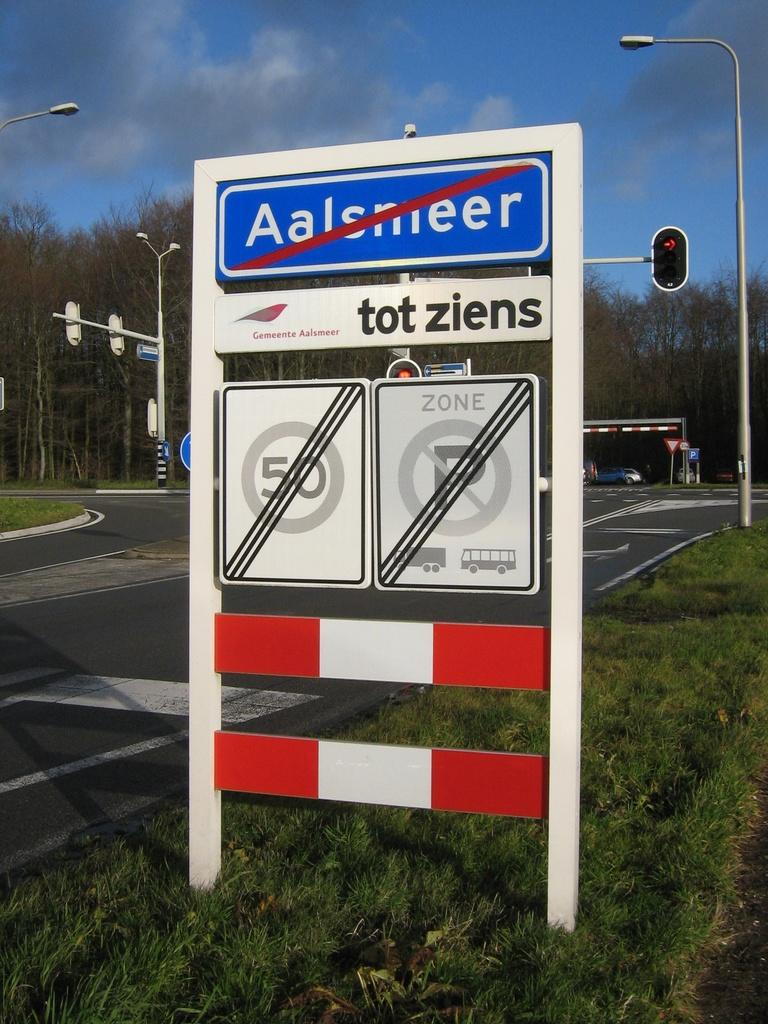<image>
Write a terse but informative summary of the picture. A German roadsign prohibits speeding, parking and has a red slash across its place name. 